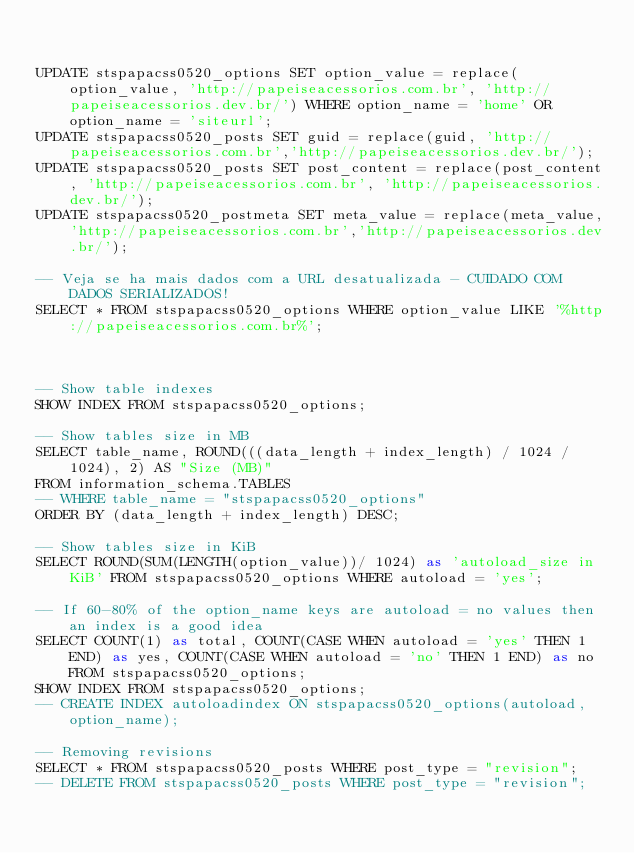<code> <loc_0><loc_0><loc_500><loc_500><_SQL_>

UPDATE stspapacss0520_options SET option_value = replace(option_value, 'http://papeiseacessorios.com.br', 'http://papeiseacessorios.dev.br/') WHERE option_name = 'home' OR option_name = 'siteurl';
UPDATE stspapacss0520_posts SET guid = replace(guid, 'http://papeiseacessorios.com.br','http://papeiseacessorios.dev.br/');
UPDATE stspapacss0520_posts SET post_content = replace(post_content, 'http://papeiseacessorios.com.br', 'http://papeiseacessorios.dev.br/');
UPDATE stspapacss0520_postmeta SET meta_value = replace(meta_value,'http://papeiseacessorios.com.br','http://papeiseacessorios.dev.br/');

-- Veja se ha mais dados com a URL desatualizada - CUIDADO COM DADOS SERIALIZADOS!
SELECT * FROM stspapacss0520_options WHERE option_value LIKE '%http://papeiseacessorios.com.br%';



-- Show table indexes
SHOW INDEX FROM stspapacss0520_options;

-- Show tables size in MB
SELECT table_name, ROUND(((data_length + index_length) / 1024 / 1024), 2) AS "Size (MB)"
FROM information_schema.TABLES
-- WHERE table_name = "stspapacss0520_options"
ORDER BY (data_length + index_length) DESC;

-- Show tables size in KiB
SELECT ROUND(SUM(LENGTH(option_value))/ 1024) as 'autoload_size in KiB' FROM stspapacss0520_options WHERE autoload = 'yes';

-- If 60-80% of the option_name keys are autoload = no values then an index is a good idea
SELECT COUNT(1) as total, COUNT(CASE WHEN autoload = 'yes' THEN 1 END) as yes, COUNT(CASE WHEN autoload = 'no' THEN 1 END) as no FROM stspapacss0520_options;
SHOW INDEX FROM stspapacss0520_options;
-- CREATE INDEX autoloadindex ON stspapacss0520_options(autoload, option_name);

-- Removing revisions
SELECT * FROM stspapacss0520_posts WHERE post_type = "revision";
-- DELETE FROM stspapacss0520_posts WHERE post_type = "revision";


</code> 